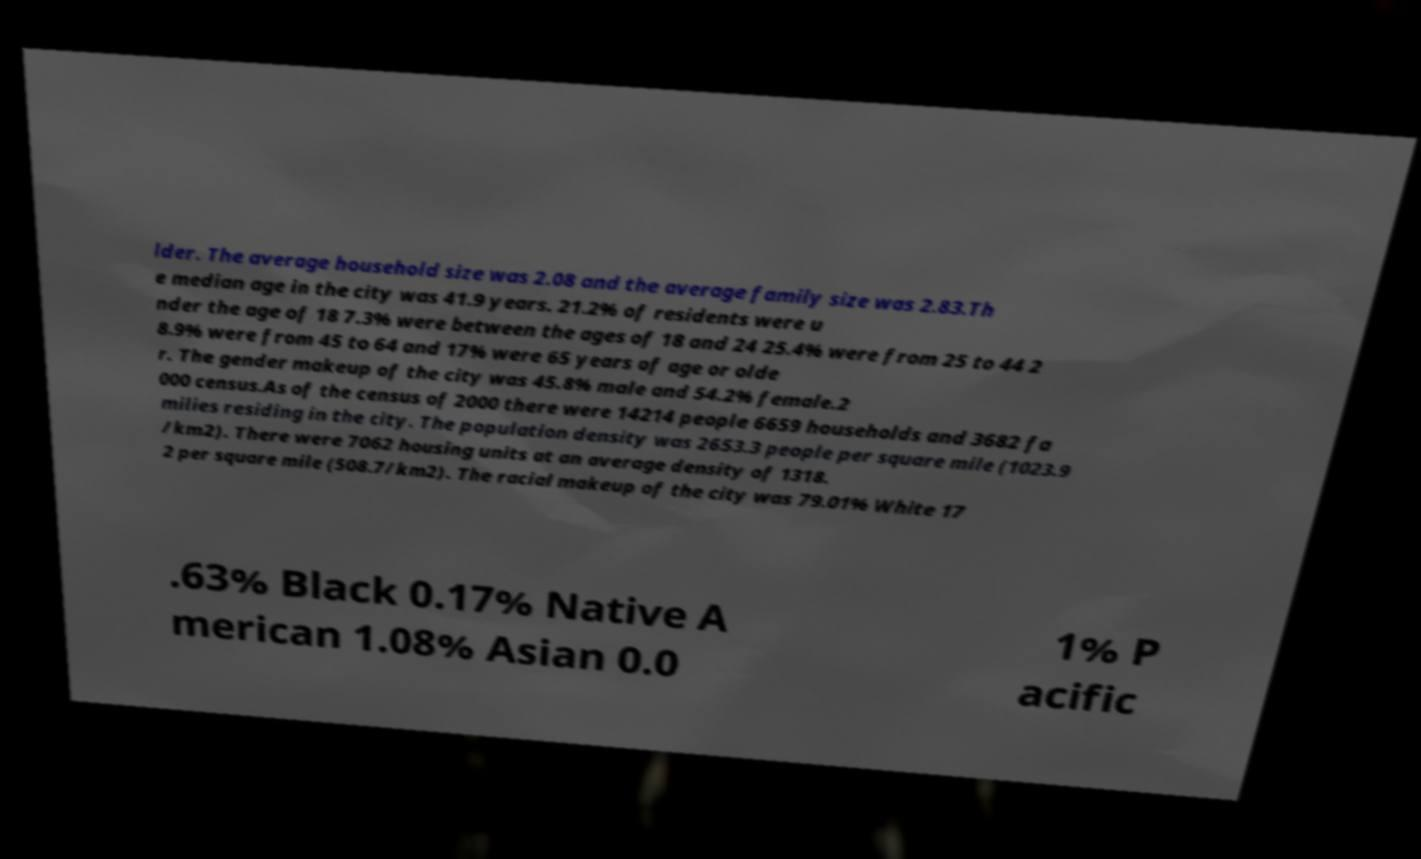Please identify and transcribe the text found in this image. lder. The average household size was 2.08 and the average family size was 2.83.Th e median age in the city was 41.9 years. 21.2% of residents were u nder the age of 18 7.3% were between the ages of 18 and 24 25.4% were from 25 to 44 2 8.9% were from 45 to 64 and 17% were 65 years of age or olde r. The gender makeup of the city was 45.8% male and 54.2% female.2 000 census.As of the census of 2000 there were 14214 people 6659 households and 3682 fa milies residing in the city. The population density was 2653.3 people per square mile (1023.9 /km2). There were 7062 housing units at an average density of 1318. 2 per square mile (508.7/km2). The racial makeup of the city was 79.01% White 17 .63% Black 0.17% Native A merican 1.08% Asian 0.0 1% P acific 